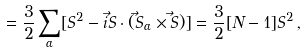Convert formula to latex. <formula><loc_0><loc_0><loc_500><loc_500>= \frac { 3 } { 2 } \sum _ { \alpha } [ S ^ { 2 } - i \vec { S } \cdot ( \vec { S } _ { \alpha } \times \vec { S } ) ] = \frac { 3 } { 2 } [ N - 1 ] S ^ { 2 } \, ,</formula> 